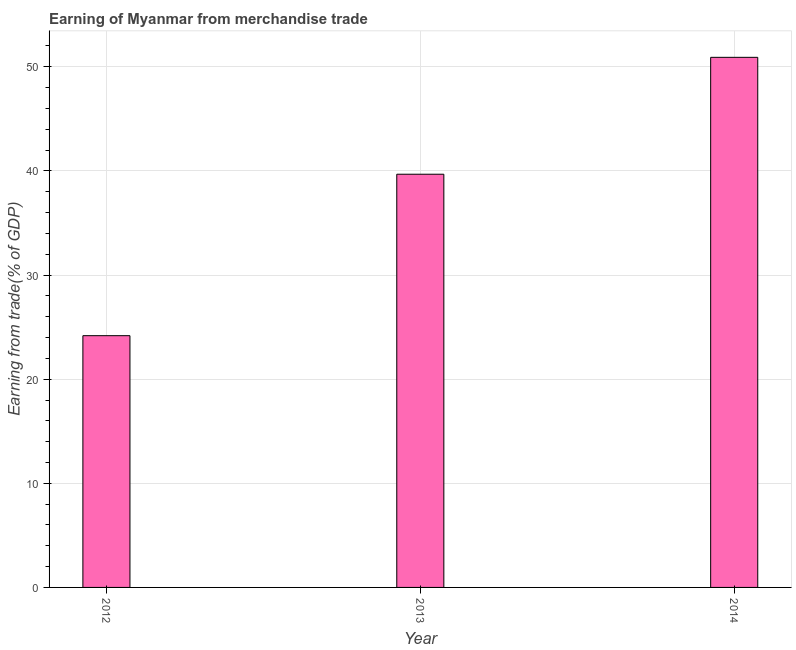Does the graph contain any zero values?
Provide a succinct answer. No. What is the title of the graph?
Ensure brevity in your answer.  Earning of Myanmar from merchandise trade. What is the label or title of the X-axis?
Offer a terse response. Year. What is the label or title of the Y-axis?
Offer a very short reply. Earning from trade(% of GDP). What is the earning from merchandise trade in 2013?
Ensure brevity in your answer.  39.68. Across all years, what is the maximum earning from merchandise trade?
Provide a succinct answer. 50.91. Across all years, what is the minimum earning from merchandise trade?
Your response must be concise. 24.18. In which year was the earning from merchandise trade maximum?
Keep it short and to the point. 2014. What is the sum of the earning from merchandise trade?
Offer a terse response. 114.77. What is the difference between the earning from merchandise trade in 2012 and 2013?
Provide a short and direct response. -15.51. What is the average earning from merchandise trade per year?
Your answer should be very brief. 38.26. What is the median earning from merchandise trade?
Keep it short and to the point. 39.68. Do a majority of the years between 2014 and 2013 (inclusive) have earning from merchandise trade greater than 50 %?
Your response must be concise. No. What is the ratio of the earning from merchandise trade in 2013 to that in 2014?
Make the answer very short. 0.78. Is the difference between the earning from merchandise trade in 2012 and 2013 greater than the difference between any two years?
Provide a succinct answer. No. What is the difference between the highest and the second highest earning from merchandise trade?
Provide a short and direct response. 11.23. What is the difference between the highest and the lowest earning from merchandise trade?
Your answer should be very brief. 26.73. In how many years, is the earning from merchandise trade greater than the average earning from merchandise trade taken over all years?
Give a very brief answer. 2. How many bars are there?
Your answer should be very brief. 3. How many years are there in the graph?
Your response must be concise. 3. What is the difference between two consecutive major ticks on the Y-axis?
Your response must be concise. 10. What is the Earning from trade(% of GDP) in 2012?
Offer a very short reply. 24.18. What is the Earning from trade(% of GDP) in 2013?
Offer a terse response. 39.68. What is the Earning from trade(% of GDP) in 2014?
Give a very brief answer. 50.91. What is the difference between the Earning from trade(% of GDP) in 2012 and 2013?
Your answer should be compact. -15.51. What is the difference between the Earning from trade(% of GDP) in 2012 and 2014?
Offer a very short reply. -26.73. What is the difference between the Earning from trade(% of GDP) in 2013 and 2014?
Provide a succinct answer. -11.23. What is the ratio of the Earning from trade(% of GDP) in 2012 to that in 2013?
Keep it short and to the point. 0.61. What is the ratio of the Earning from trade(% of GDP) in 2012 to that in 2014?
Provide a short and direct response. 0.47. What is the ratio of the Earning from trade(% of GDP) in 2013 to that in 2014?
Your response must be concise. 0.78. 